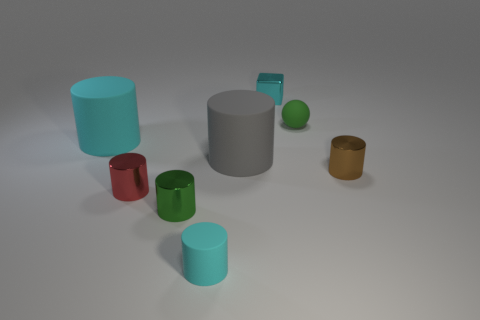Subtract all large cylinders. How many cylinders are left? 4 Subtract all cyan cylinders. How many cylinders are left? 4 Add 1 gray cylinders. How many objects exist? 9 Subtract all cylinders. Subtract all cubes. How many objects are left? 1 Add 3 tiny red cylinders. How many tiny red cylinders are left? 4 Add 4 small cyan cubes. How many small cyan cubes exist? 5 Subtract 1 cyan blocks. How many objects are left? 7 Subtract all cylinders. How many objects are left? 2 Subtract 1 balls. How many balls are left? 0 Subtract all brown cylinders. Subtract all purple cubes. How many cylinders are left? 5 